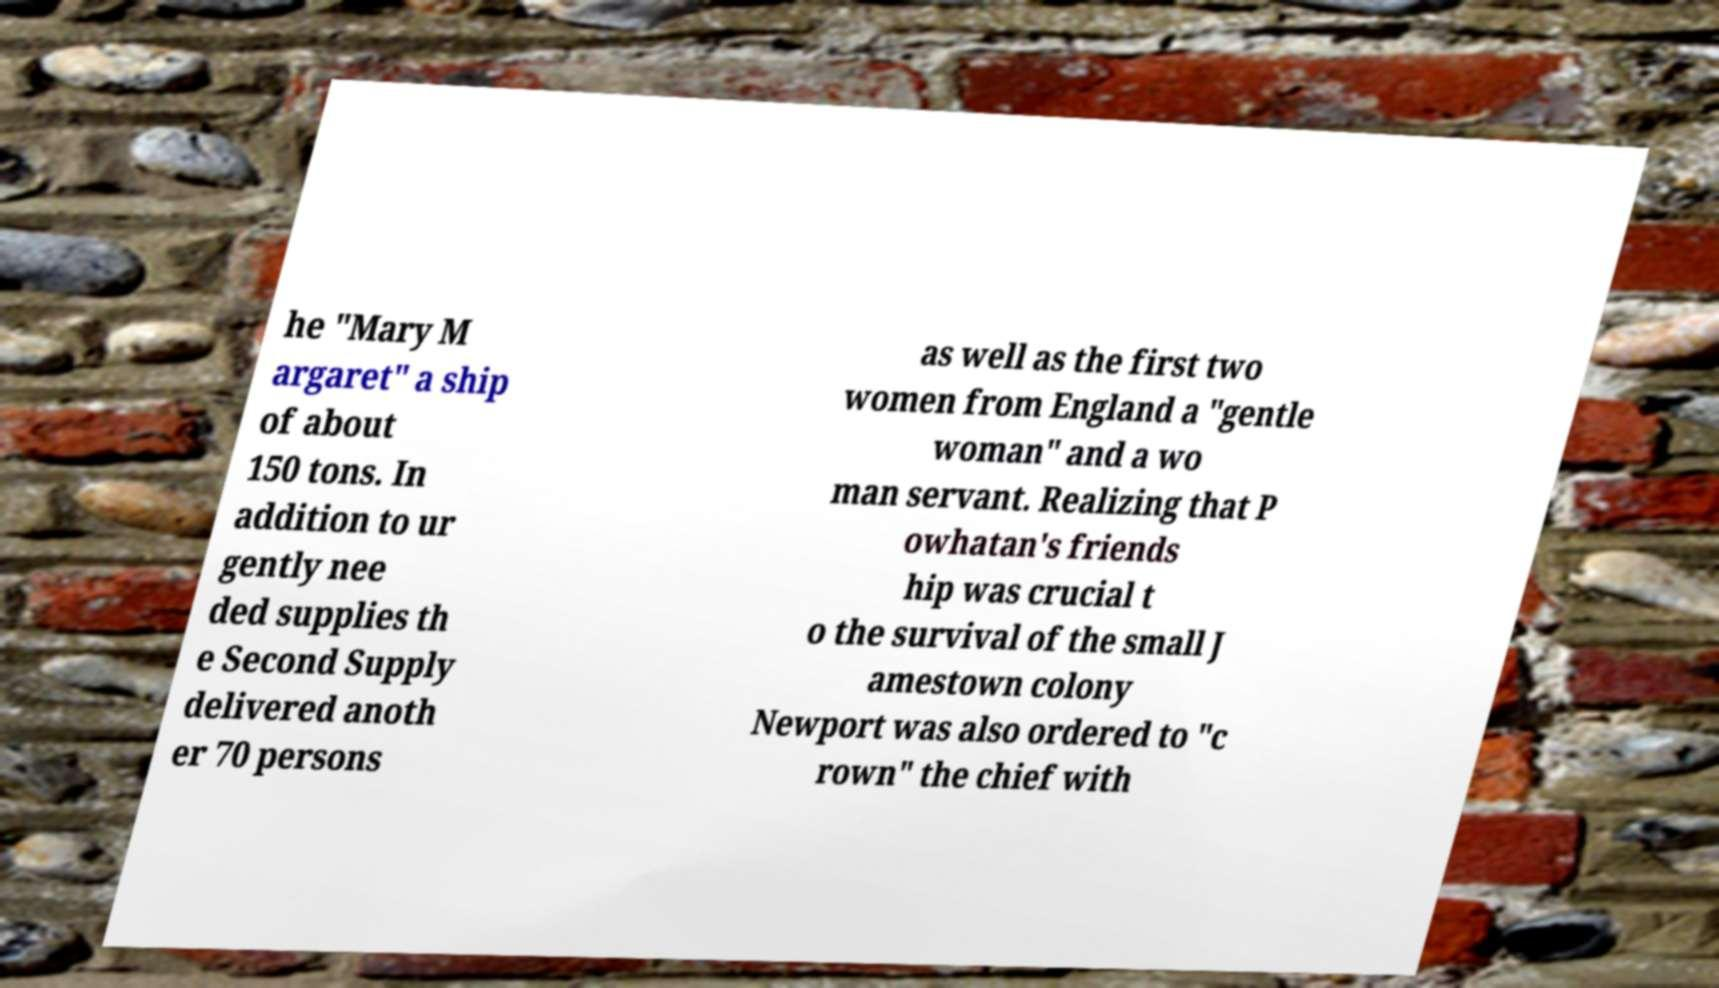There's text embedded in this image that I need extracted. Can you transcribe it verbatim? he "Mary M argaret" a ship of about 150 tons. In addition to ur gently nee ded supplies th e Second Supply delivered anoth er 70 persons as well as the first two women from England a "gentle woman" and a wo man servant. Realizing that P owhatan's friends hip was crucial t o the survival of the small J amestown colony Newport was also ordered to "c rown" the chief with 